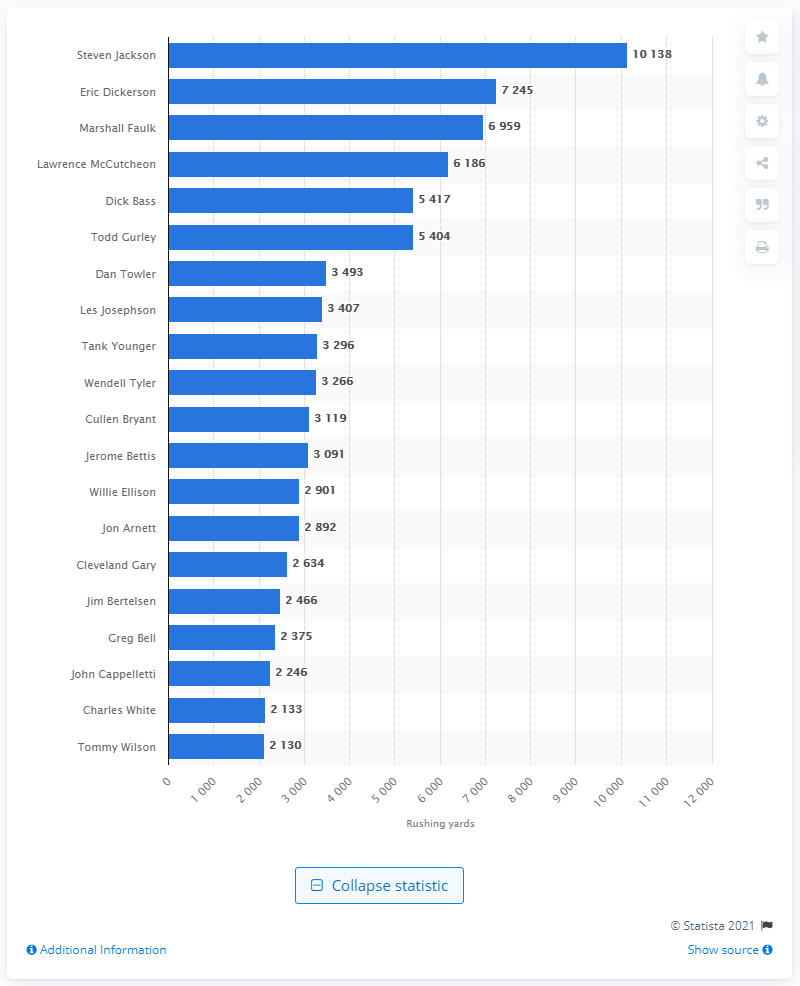Specify some key components in this picture. Steven Jackson is the career rushing leader of the Los Angeles Rams. 